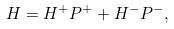Convert formula to latex. <formula><loc_0><loc_0><loc_500><loc_500>H = H ^ { + } P ^ { + } + H ^ { - } P ^ { - } ,</formula> 